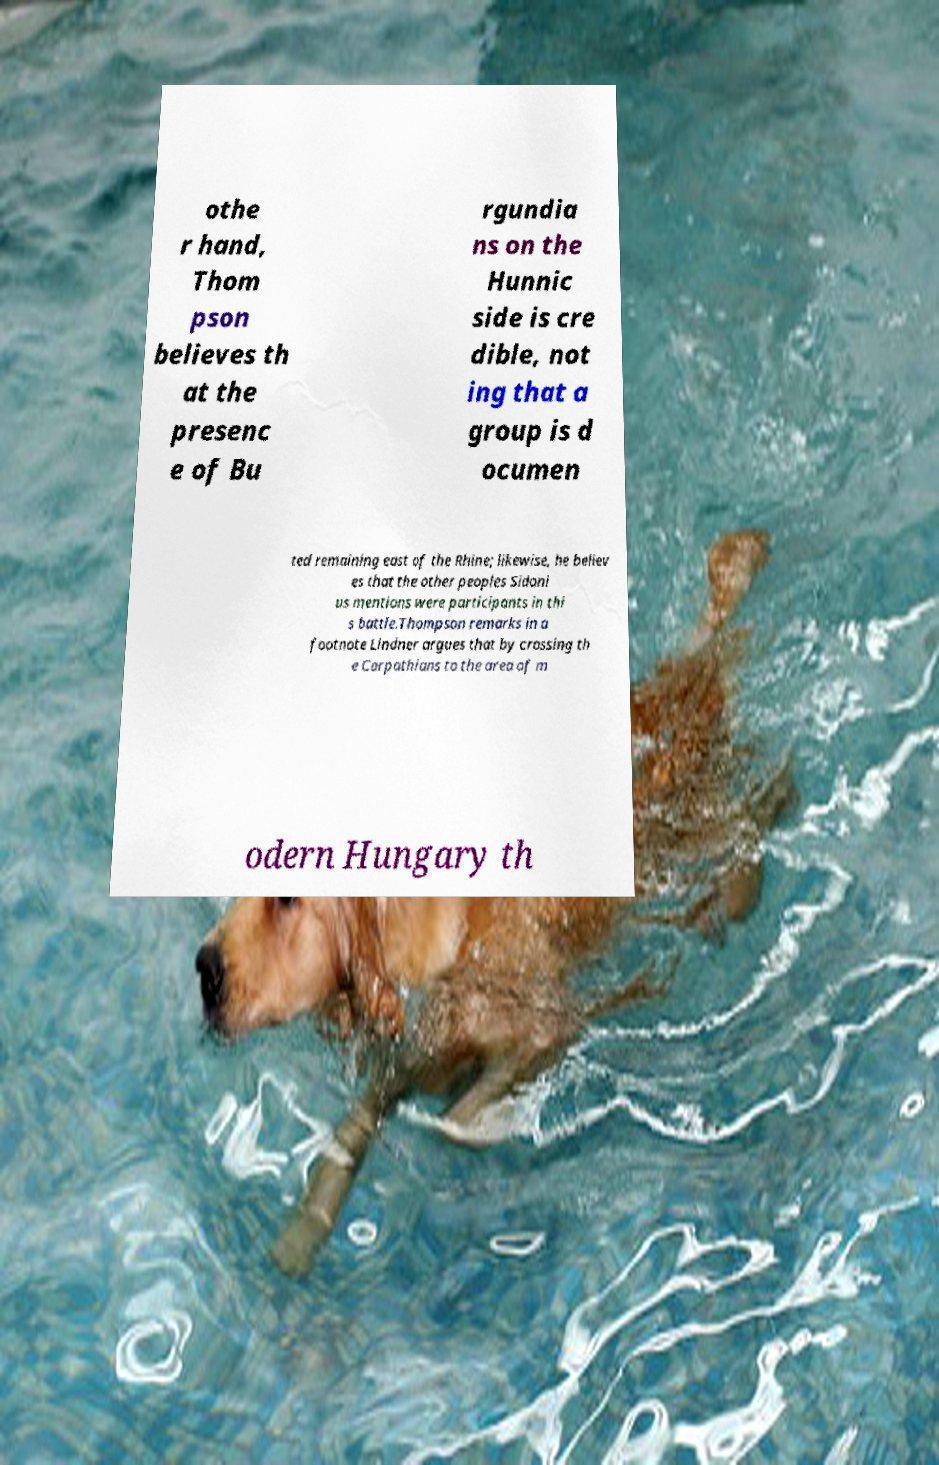Please identify and transcribe the text found in this image. othe r hand, Thom pson believes th at the presenc e of Bu rgundia ns on the Hunnic side is cre dible, not ing that a group is d ocumen ted remaining east of the Rhine; likewise, he believ es that the other peoples Sidoni us mentions were participants in thi s battle.Thompson remarks in a footnote Lindner argues that by crossing th e Carpathians to the area of m odern Hungary th 